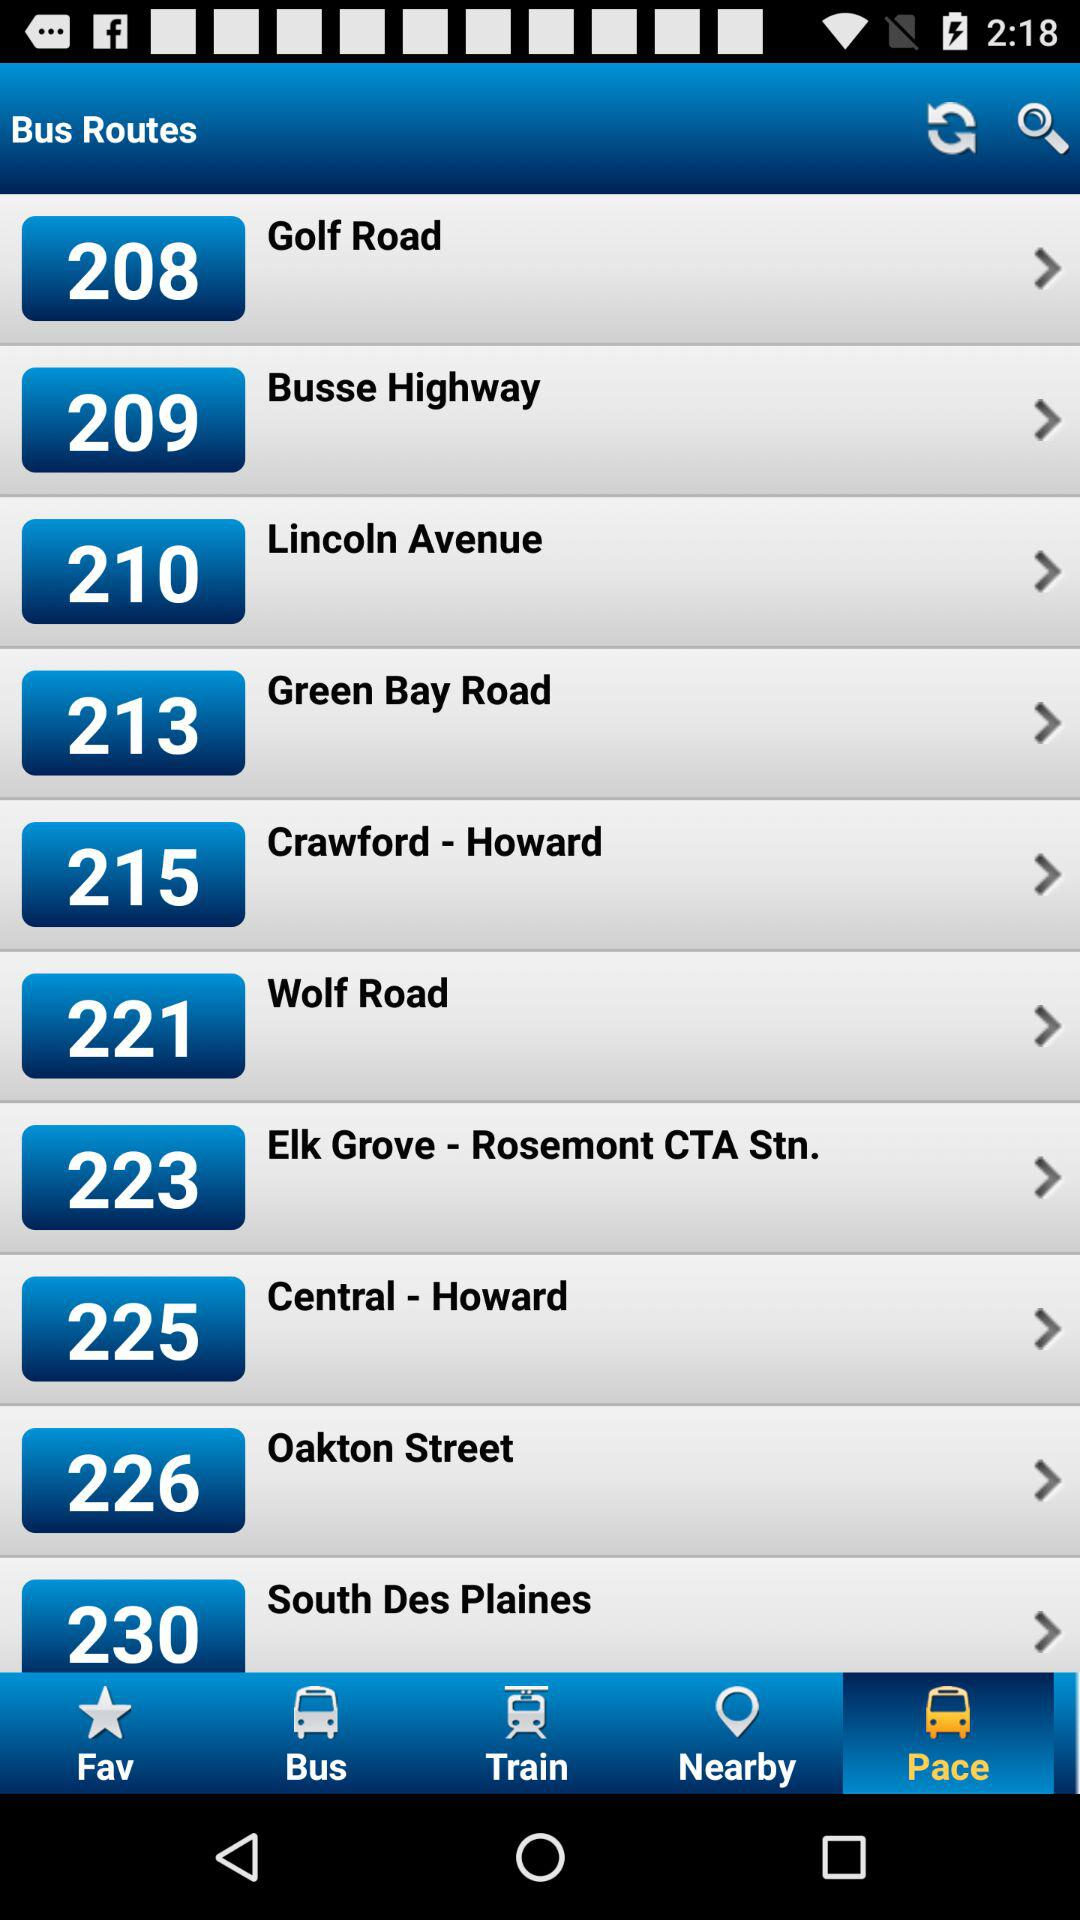Can you tell me about the destinations of the highlighted bus routes? Certainly! Based on the image, the destinations of the highlighted bus routes include Golf Road, Busse Highway, Lincoln Avenue, Green Bay Road, Crawford - Howard, Wolf Road, Elk Grove - Rosemont CTA Station, Central - Howard, Oakton Street, and South Des Plaines. 